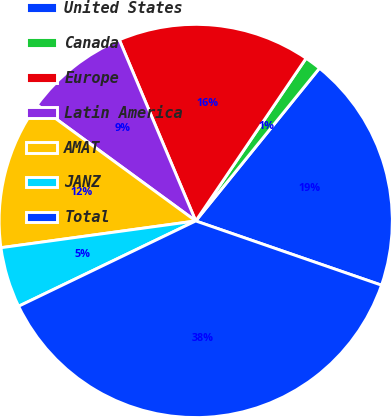Convert chart. <chart><loc_0><loc_0><loc_500><loc_500><pie_chart><fcel>United States<fcel>Canada<fcel>Europe<fcel>Latin America<fcel>AMAT<fcel>JANZ<fcel>Total<nl><fcel>19.46%<fcel>1.35%<fcel>15.84%<fcel>8.6%<fcel>12.22%<fcel>4.97%<fcel>37.56%<nl></chart> 